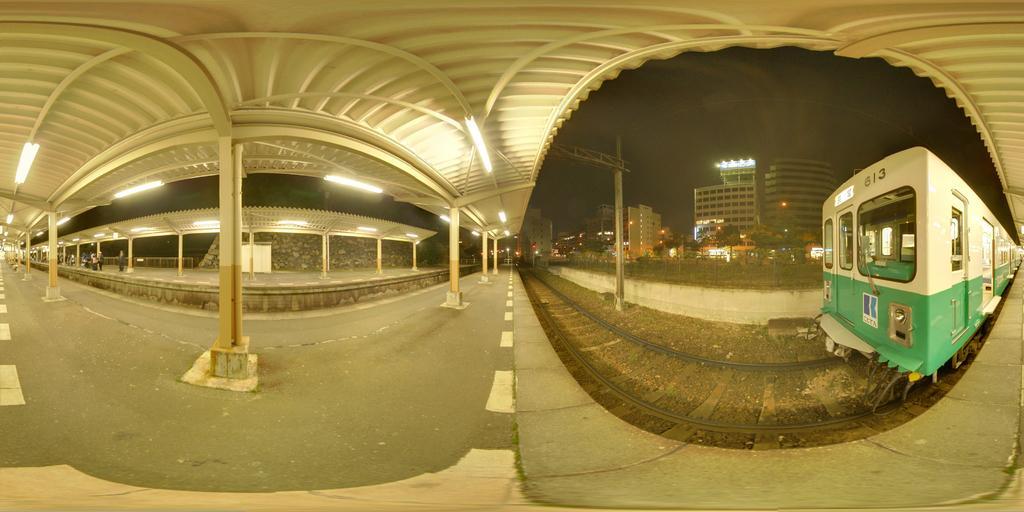Can you describe this image briefly? In this image on the left side there is a walkway, pillars, lights, wall. At the top there is ceiling, and on the right side of the image there is a railway track, train, poles, fence, buildings, trees, lights and sky. 